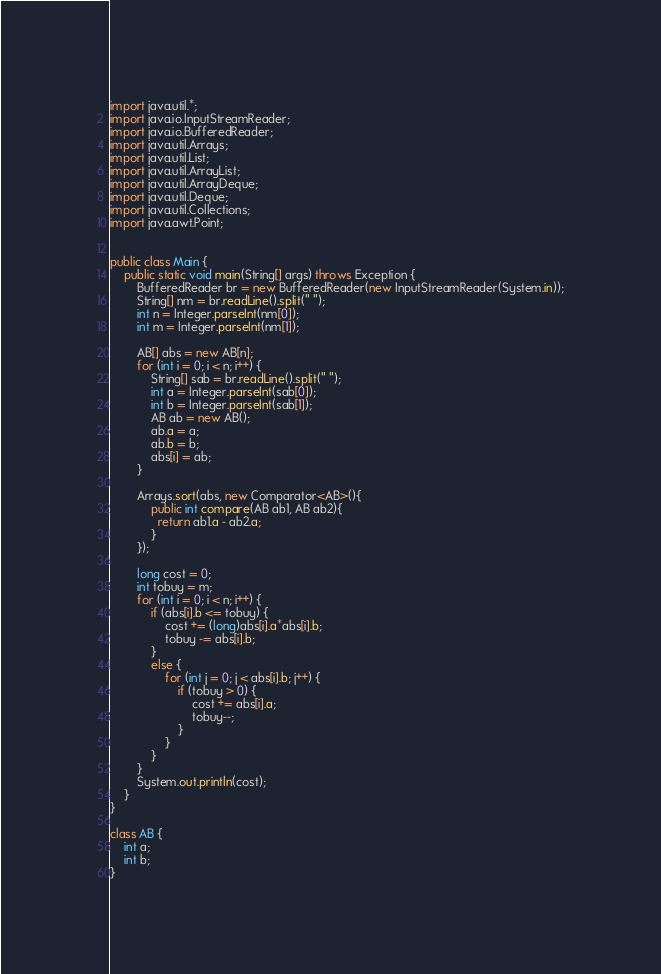<code> <loc_0><loc_0><loc_500><loc_500><_Java_>import java.util.*;
import java.io.InputStreamReader;
import java.io.BufferedReader;
import java.util.Arrays;
import java.util.List;
import java.util.ArrayList;
import java.util.ArrayDeque;
import java.util.Deque;
import java.util.Collections;
import java.awt.Point;


public class Main {
    public static void main(String[] args) throws Exception {
        BufferedReader br = new BufferedReader(new InputStreamReader(System.in));
        String[] nm = br.readLine().split(" ");
        int n = Integer.parseInt(nm[0]);
        int m = Integer.parseInt(nm[1]);
        
        AB[] abs = new AB[n];
        for (int i = 0; i < n; i++) {
            String[] sab = br.readLine().split(" ");
            int a = Integer.parseInt(sab[0]);
            int b = Integer.parseInt(sab[1]);
            AB ab = new AB();
            ab.a = a;
            ab.b = b;
            abs[i] = ab;
        }
        
        Arrays.sort(abs, new Comparator<AB>(){
            public int compare(AB ab1, AB ab2){
              return ab1.a - ab2.a;
            }
        });
        
        long cost = 0;
        int tobuy = m;
        for (int i = 0; i < n; i++) {
            if (abs[i].b <= tobuy) {
                cost += (long)abs[i].a*abs[i].b;
                tobuy -= abs[i].b;
            }
            else {
                for (int j = 0; j < abs[i].b; j++) {
                    if (tobuy > 0) {
                        cost += abs[i].a;
                        tobuy--;
                    }
                }
            }
        }
        System.out.println(cost);
    }
}

class AB {
    int a;
    int b;
}

</code> 